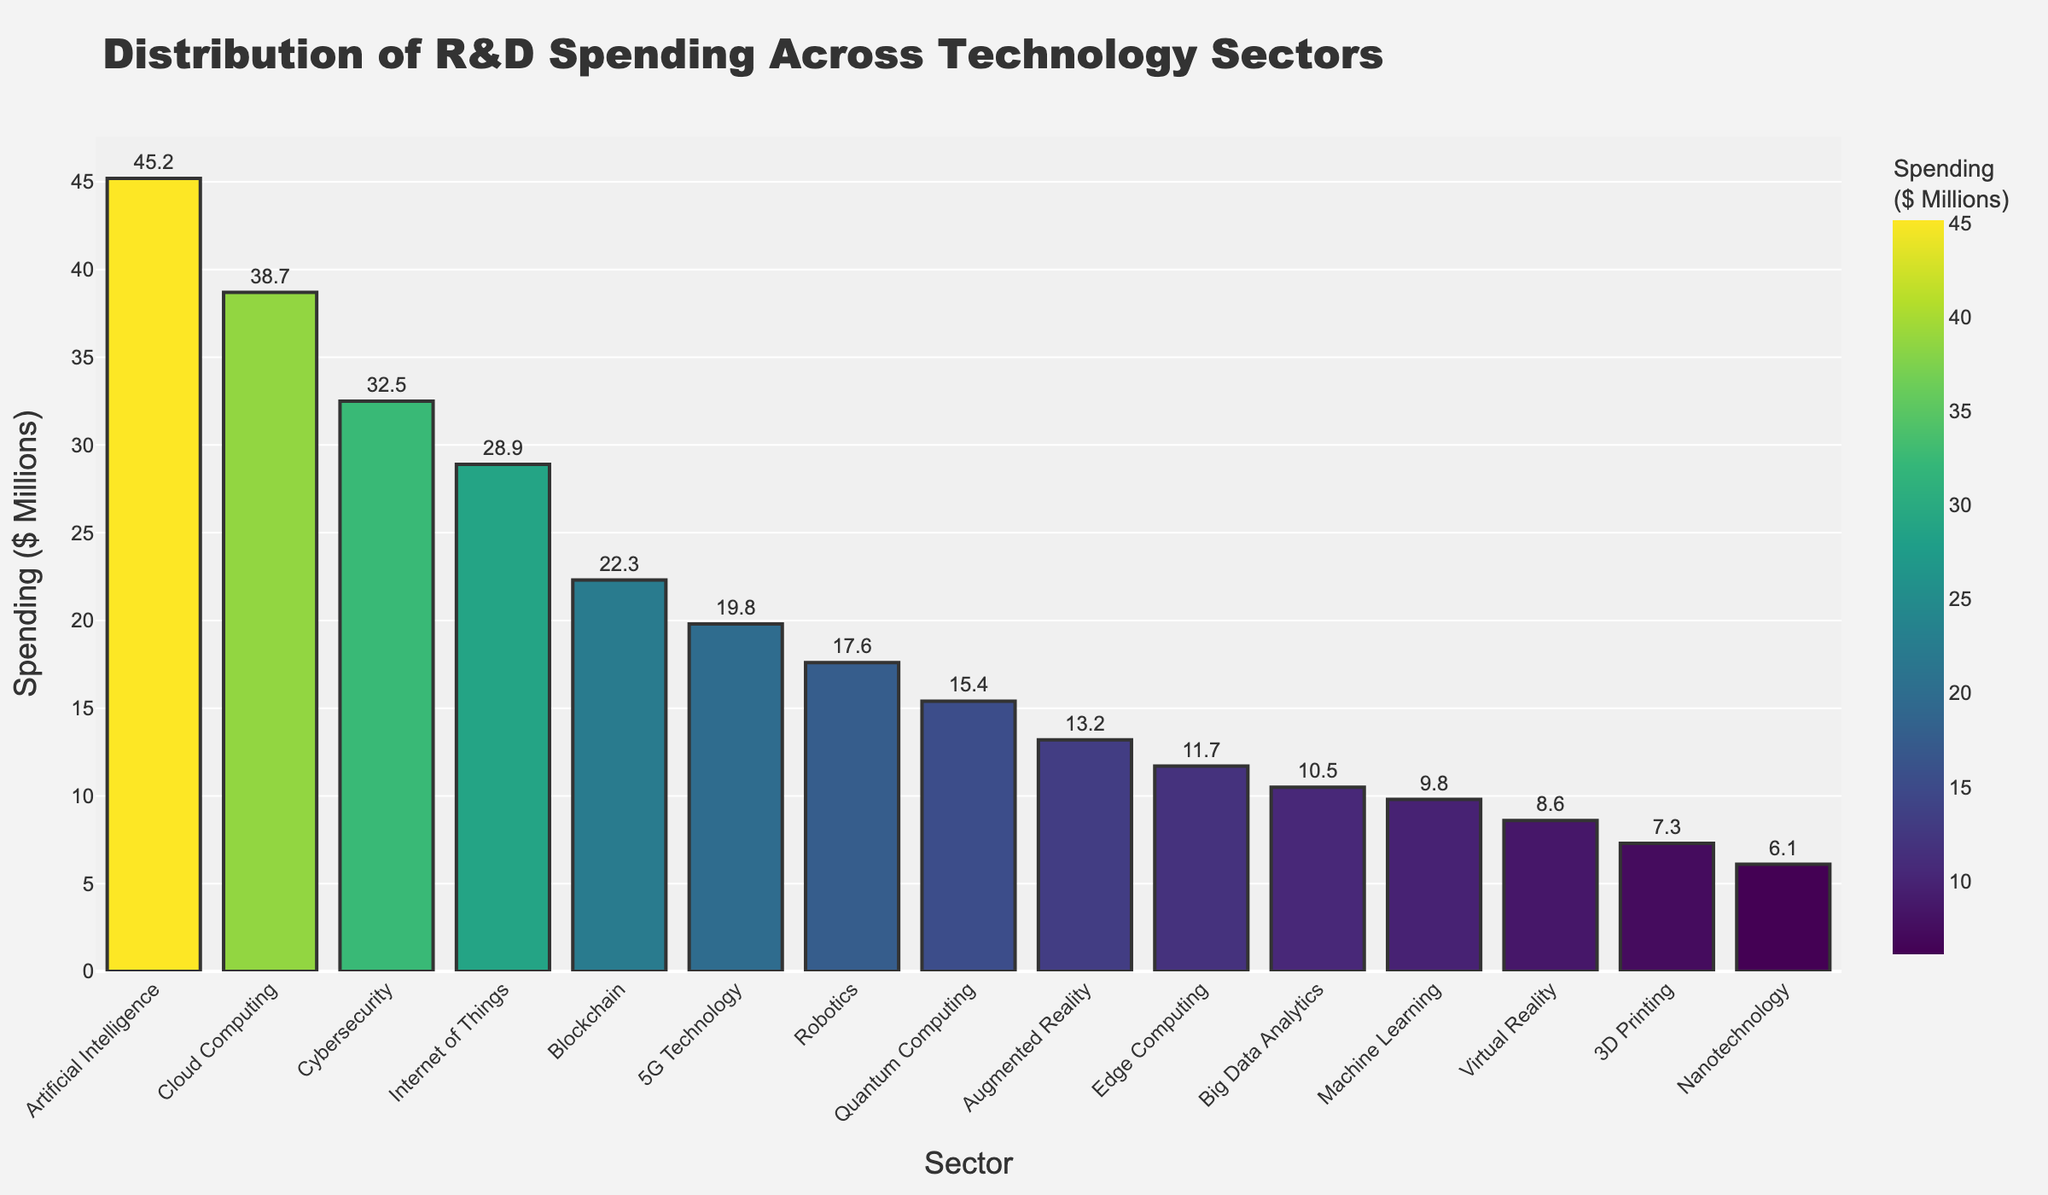What's the total R&D spending on 'Artificial Intelligence', 'Machine Learning', and 'Virtual Reality'? Add the R&D spending values for the three sectors: 45.2 (AI) + 9.8 (ML) + 8.6 (VR). This gives 63.6.
Answer: 63.6 Which technology sector received the highest R&D spending, and how much was it? Look at the tallest bar on the chart, which is 'Artificial Intelligence', with an R&D spending amount of 45.2 million dollars.
Answer: Artificial Intelligence, 45.2 Which technology sector received the lowest R&D spending? Look at the shortest bar, which represents 'Nanotechnology' with an R&D spending amount of 6.1 million dollars.
Answer: Nanotechnology How much more was spent on 'Artificial Intelligence' compared to 'Big Data Analytics'? Subtract the R&D spending for 'Big Data Analytics' from that for 'Artificial Intelligence': 45.2 - 10.5 = 34.7.
Answer: 34.7 What is the average R&D spending for 'Blockchain', '5G Technology', and 'Quantum Computing'? Add the R&D spending for 'Blockchain' (22.3), '5G Technology' (19.8), and 'Quantum Computing' (15.4), then divide by 3: (22.3 + 19.8 + 15.4) / 3 = 19.167.
Answer: 19.167 Out of 'Edge Computing' and '3D Printing', which sector had higher R&D spending? Compare the heights of the bars for 'Edge Computing' (11.7) and '3D Printing' (7.3). 'Edge Computing' has higher spending.
Answer: Edge Computing What are the total R&D expenditures for sectors with R&D spending less than 15 million dollars? Sum the R&D spending values for 'Augmented Reality' (13.2), 'Edge Computing' (11.7), 'Big Data Analytics' (10.5), 'Machine Learning' (9.8), 'Virtual Reality' (8.6), '3D Printing' (7.3), and 'Nanotechnology' (6.1): 13.2 + 11.7 + 10.5 + 9.8 + 8.6 + 7.3 + 6.1 = 67.2.
Answer: 67.2 How many sectors have R&D spending greater than 20 million dollars? Count the bars with a height corresponding to an R&D spending amount greater than 20 million dollars: 'Artificial Intelligence', 'Cloud Computing', 'Cybersecurity', 'Internet of Things', and 'Blockchain'. There are 5 sectors in total.
Answer: 5 